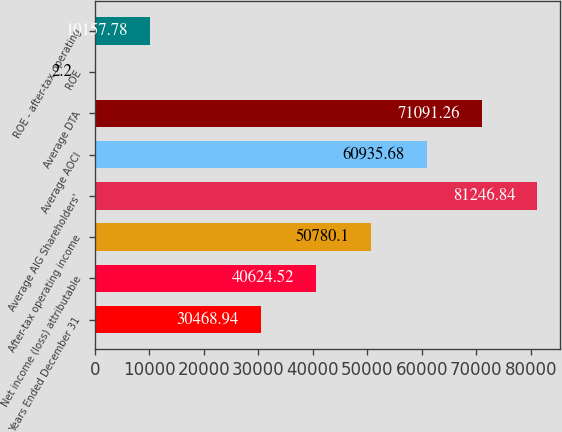Convert chart to OTSL. <chart><loc_0><loc_0><loc_500><loc_500><bar_chart><fcel>Years Ended December 31<fcel>Net income (loss) attributable<fcel>After-tax operating income<fcel>Average AIG Shareholders'<fcel>Average AOCI<fcel>Average DTA<fcel>ROE<fcel>ROE - after-tax operating<nl><fcel>30468.9<fcel>40624.5<fcel>50780.1<fcel>81246.8<fcel>60935.7<fcel>71091.3<fcel>2.2<fcel>10157.8<nl></chart> 